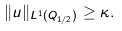<formula> <loc_0><loc_0><loc_500><loc_500>\| u \| _ { L ^ { 1 } ( Q _ { 1 / 2 } ) } \geq \kappa .</formula> 